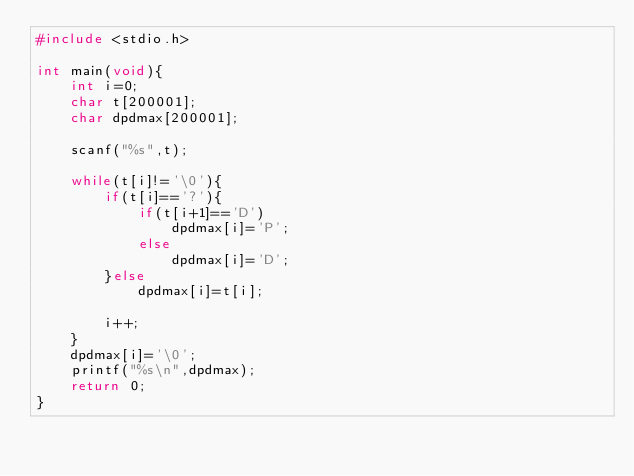Convert code to text. <code><loc_0><loc_0><loc_500><loc_500><_C_>#include <stdio.h>

int main(void){
    int i=0;
    char t[200001];
    char dpdmax[200001];
    
    scanf("%s",t);
    
    while(t[i]!='\0'){
        if(t[i]=='?'){
            if(t[i+1]=='D')
                dpdmax[i]='P';
            else
                dpdmax[i]='D';
        }else
            dpdmax[i]=t[i];
            
        i++;
    }
    dpdmax[i]='\0';
    printf("%s\n",dpdmax);
    return 0;
}
</code> 